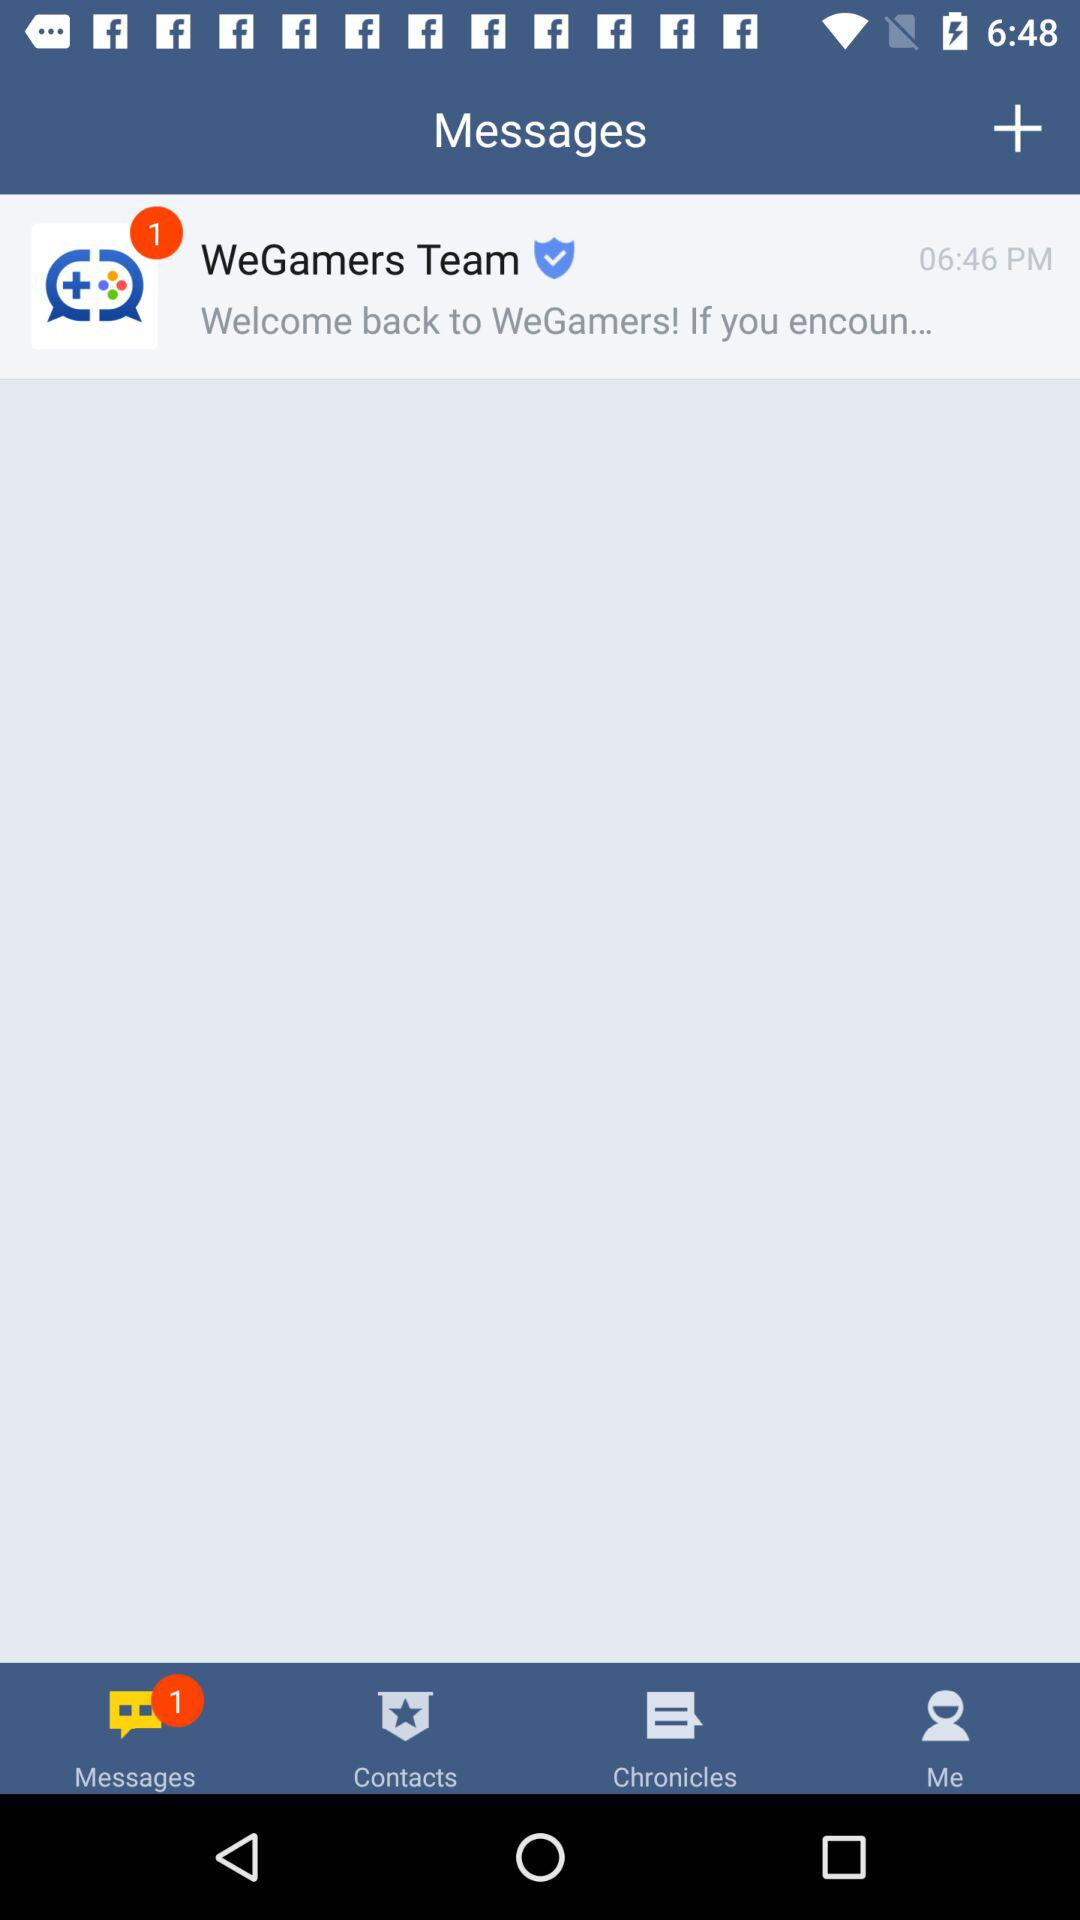Which tab is selected? The selected tab is "Messages". 